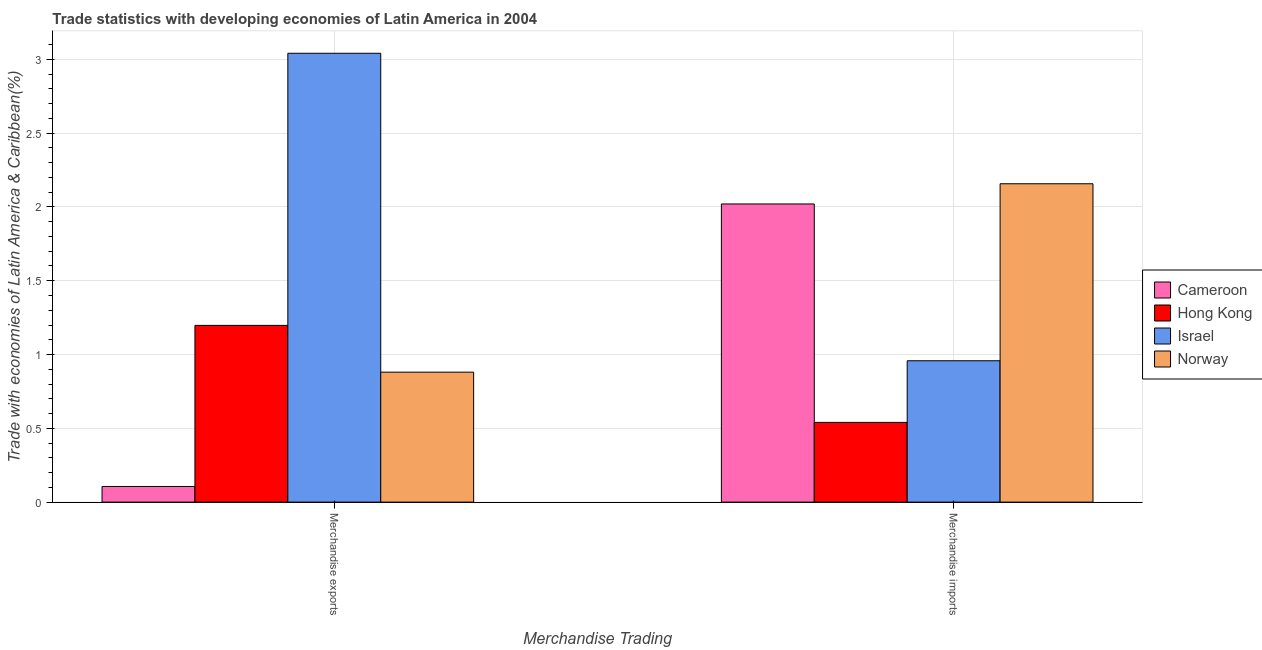How many groups of bars are there?
Offer a terse response. 2. What is the merchandise exports in Israel?
Provide a succinct answer. 3.04. Across all countries, what is the maximum merchandise imports?
Provide a short and direct response. 2.16. Across all countries, what is the minimum merchandise imports?
Make the answer very short. 0.54. In which country was the merchandise exports minimum?
Your response must be concise. Cameroon. What is the total merchandise exports in the graph?
Your answer should be compact. 5.23. What is the difference between the merchandise imports in Israel and that in Cameroon?
Give a very brief answer. -1.06. What is the difference between the merchandise imports in Norway and the merchandise exports in Cameroon?
Offer a very short reply. 2.05. What is the average merchandise imports per country?
Your answer should be very brief. 1.42. What is the difference between the merchandise exports and merchandise imports in Norway?
Offer a terse response. -1.28. In how many countries, is the merchandise imports greater than 2 %?
Give a very brief answer. 2. What is the ratio of the merchandise exports in Norway to that in Hong Kong?
Your answer should be very brief. 0.74. Is the merchandise exports in Norway less than that in Cameroon?
Provide a short and direct response. No. In how many countries, is the merchandise exports greater than the average merchandise exports taken over all countries?
Offer a terse response. 1. What does the 4th bar from the left in Merchandise exports represents?
Keep it short and to the point. Norway. What does the 3rd bar from the right in Merchandise exports represents?
Your answer should be very brief. Hong Kong. How many bars are there?
Provide a short and direct response. 8. Are all the bars in the graph horizontal?
Your response must be concise. No. How many countries are there in the graph?
Give a very brief answer. 4. Does the graph contain grids?
Offer a terse response. Yes. Where does the legend appear in the graph?
Provide a succinct answer. Center right. How many legend labels are there?
Offer a terse response. 4. How are the legend labels stacked?
Ensure brevity in your answer.  Vertical. What is the title of the graph?
Your answer should be compact. Trade statistics with developing economies of Latin America in 2004. What is the label or title of the X-axis?
Offer a very short reply. Merchandise Trading. What is the label or title of the Y-axis?
Keep it short and to the point. Trade with economies of Latin America & Caribbean(%). What is the Trade with economies of Latin America & Caribbean(%) of Cameroon in Merchandise exports?
Make the answer very short. 0.11. What is the Trade with economies of Latin America & Caribbean(%) of Hong Kong in Merchandise exports?
Your response must be concise. 1.2. What is the Trade with economies of Latin America & Caribbean(%) in Israel in Merchandise exports?
Your answer should be very brief. 3.04. What is the Trade with economies of Latin America & Caribbean(%) in Norway in Merchandise exports?
Keep it short and to the point. 0.88. What is the Trade with economies of Latin America & Caribbean(%) of Cameroon in Merchandise imports?
Offer a terse response. 2.02. What is the Trade with economies of Latin America & Caribbean(%) of Hong Kong in Merchandise imports?
Provide a short and direct response. 0.54. What is the Trade with economies of Latin America & Caribbean(%) in Israel in Merchandise imports?
Your response must be concise. 0.96. What is the Trade with economies of Latin America & Caribbean(%) of Norway in Merchandise imports?
Offer a terse response. 2.16. Across all Merchandise Trading, what is the maximum Trade with economies of Latin America & Caribbean(%) of Cameroon?
Ensure brevity in your answer.  2.02. Across all Merchandise Trading, what is the maximum Trade with economies of Latin America & Caribbean(%) of Hong Kong?
Your answer should be compact. 1.2. Across all Merchandise Trading, what is the maximum Trade with economies of Latin America & Caribbean(%) of Israel?
Your answer should be compact. 3.04. Across all Merchandise Trading, what is the maximum Trade with economies of Latin America & Caribbean(%) in Norway?
Your answer should be very brief. 2.16. Across all Merchandise Trading, what is the minimum Trade with economies of Latin America & Caribbean(%) in Cameroon?
Ensure brevity in your answer.  0.11. Across all Merchandise Trading, what is the minimum Trade with economies of Latin America & Caribbean(%) in Hong Kong?
Your response must be concise. 0.54. Across all Merchandise Trading, what is the minimum Trade with economies of Latin America & Caribbean(%) of Israel?
Ensure brevity in your answer.  0.96. Across all Merchandise Trading, what is the minimum Trade with economies of Latin America & Caribbean(%) of Norway?
Your answer should be compact. 0.88. What is the total Trade with economies of Latin America & Caribbean(%) of Cameroon in the graph?
Provide a succinct answer. 2.13. What is the total Trade with economies of Latin America & Caribbean(%) of Hong Kong in the graph?
Keep it short and to the point. 1.74. What is the total Trade with economies of Latin America & Caribbean(%) in Israel in the graph?
Ensure brevity in your answer.  4. What is the total Trade with economies of Latin America & Caribbean(%) in Norway in the graph?
Keep it short and to the point. 3.04. What is the difference between the Trade with economies of Latin America & Caribbean(%) in Cameroon in Merchandise exports and that in Merchandise imports?
Provide a short and direct response. -1.91. What is the difference between the Trade with economies of Latin America & Caribbean(%) of Hong Kong in Merchandise exports and that in Merchandise imports?
Your answer should be compact. 0.66. What is the difference between the Trade with economies of Latin America & Caribbean(%) in Israel in Merchandise exports and that in Merchandise imports?
Make the answer very short. 2.08. What is the difference between the Trade with economies of Latin America & Caribbean(%) in Norway in Merchandise exports and that in Merchandise imports?
Ensure brevity in your answer.  -1.28. What is the difference between the Trade with economies of Latin America & Caribbean(%) of Cameroon in Merchandise exports and the Trade with economies of Latin America & Caribbean(%) of Hong Kong in Merchandise imports?
Provide a succinct answer. -0.43. What is the difference between the Trade with economies of Latin America & Caribbean(%) in Cameroon in Merchandise exports and the Trade with economies of Latin America & Caribbean(%) in Israel in Merchandise imports?
Your response must be concise. -0.85. What is the difference between the Trade with economies of Latin America & Caribbean(%) of Cameroon in Merchandise exports and the Trade with economies of Latin America & Caribbean(%) of Norway in Merchandise imports?
Keep it short and to the point. -2.05. What is the difference between the Trade with economies of Latin America & Caribbean(%) of Hong Kong in Merchandise exports and the Trade with economies of Latin America & Caribbean(%) of Israel in Merchandise imports?
Offer a terse response. 0.24. What is the difference between the Trade with economies of Latin America & Caribbean(%) of Hong Kong in Merchandise exports and the Trade with economies of Latin America & Caribbean(%) of Norway in Merchandise imports?
Your answer should be very brief. -0.96. What is the difference between the Trade with economies of Latin America & Caribbean(%) of Israel in Merchandise exports and the Trade with economies of Latin America & Caribbean(%) of Norway in Merchandise imports?
Give a very brief answer. 0.88. What is the average Trade with economies of Latin America & Caribbean(%) in Cameroon per Merchandise Trading?
Provide a short and direct response. 1.06. What is the average Trade with economies of Latin America & Caribbean(%) of Hong Kong per Merchandise Trading?
Your answer should be compact. 0.87. What is the average Trade with economies of Latin America & Caribbean(%) in Israel per Merchandise Trading?
Your answer should be compact. 2. What is the average Trade with economies of Latin America & Caribbean(%) of Norway per Merchandise Trading?
Keep it short and to the point. 1.52. What is the difference between the Trade with economies of Latin America & Caribbean(%) of Cameroon and Trade with economies of Latin America & Caribbean(%) of Hong Kong in Merchandise exports?
Offer a terse response. -1.09. What is the difference between the Trade with economies of Latin America & Caribbean(%) in Cameroon and Trade with economies of Latin America & Caribbean(%) in Israel in Merchandise exports?
Make the answer very short. -2.94. What is the difference between the Trade with economies of Latin America & Caribbean(%) of Cameroon and Trade with economies of Latin America & Caribbean(%) of Norway in Merchandise exports?
Give a very brief answer. -0.77. What is the difference between the Trade with economies of Latin America & Caribbean(%) in Hong Kong and Trade with economies of Latin America & Caribbean(%) in Israel in Merchandise exports?
Keep it short and to the point. -1.84. What is the difference between the Trade with economies of Latin America & Caribbean(%) of Hong Kong and Trade with economies of Latin America & Caribbean(%) of Norway in Merchandise exports?
Your response must be concise. 0.32. What is the difference between the Trade with economies of Latin America & Caribbean(%) in Israel and Trade with economies of Latin America & Caribbean(%) in Norway in Merchandise exports?
Make the answer very short. 2.16. What is the difference between the Trade with economies of Latin America & Caribbean(%) of Cameroon and Trade with economies of Latin America & Caribbean(%) of Hong Kong in Merchandise imports?
Ensure brevity in your answer.  1.48. What is the difference between the Trade with economies of Latin America & Caribbean(%) in Cameroon and Trade with economies of Latin America & Caribbean(%) in Israel in Merchandise imports?
Provide a short and direct response. 1.06. What is the difference between the Trade with economies of Latin America & Caribbean(%) of Cameroon and Trade with economies of Latin America & Caribbean(%) of Norway in Merchandise imports?
Make the answer very short. -0.14. What is the difference between the Trade with economies of Latin America & Caribbean(%) in Hong Kong and Trade with economies of Latin America & Caribbean(%) in Israel in Merchandise imports?
Offer a very short reply. -0.42. What is the difference between the Trade with economies of Latin America & Caribbean(%) in Hong Kong and Trade with economies of Latin America & Caribbean(%) in Norway in Merchandise imports?
Your response must be concise. -1.62. What is the difference between the Trade with economies of Latin America & Caribbean(%) of Israel and Trade with economies of Latin America & Caribbean(%) of Norway in Merchandise imports?
Keep it short and to the point. -1.2. What is the ratio of the Trade with economies of Latin America & Caribbean(%) of Cameroon in Merchandise exports to that in Merchandise imports?
Ensure brevity in your answer.  0.05. What is the ratio of the Trade with economies of Latin America & Caribbean(%) in Hong Kong in Merchandise exports to that in Merchandise imports?
Make the answer very short. 2.22. What is the ratio of the Trade with economies of Latin America & Caribbean(%) in Israel in Merchandise exports to that in Merchandise imports?
Keep it short and to the point. 3.17. What is the ratio of the Trade with economies of Latin America & Caribbean(%) of Norway in Merchandise exports to that in Merchandise imports?
Give a very brief answer. 0.41. What is the difference between the highest and the second highest Trade with economies of Latin America & Caribbean(%) in Cameroon?
Make the answer very short. 1.91. What is the difference between the highest and the second highest Trade with economies of Latin America & Caribbean(%) of Hong Kong?
Offer a terse response. 0.66. What is the difference between the highest and the second highest Trade with economies of Latin America & Caribbean(%) in Israel?
Offer a very short reply. 2.08. What is the difference between the highest and the second highest Trade with economies of Latin America & Caribbean(%) of Norway?
Offer a terse response. 1.28. What is the difference between the highest and the lowest Trade with economies of Latin America & Caribbean(%) in Cameroon?
Keep it short and to the point. 1.91. What is the difference between the highest and the lowest Trade with economies of Latin America & Caribbean(%) in Hong Kong?
Keep it short and to the point. 0.66. What is the difference between the highest and the lowest Trade with economies of Latin America & Caribbean(%) of Israel?
Your answer should be compact. 2.08. What is the difference between the highest and the lowest Trade with economies of Latin America & Caribbean(%) of Norway?
Give a very brief answer. 1.28. 